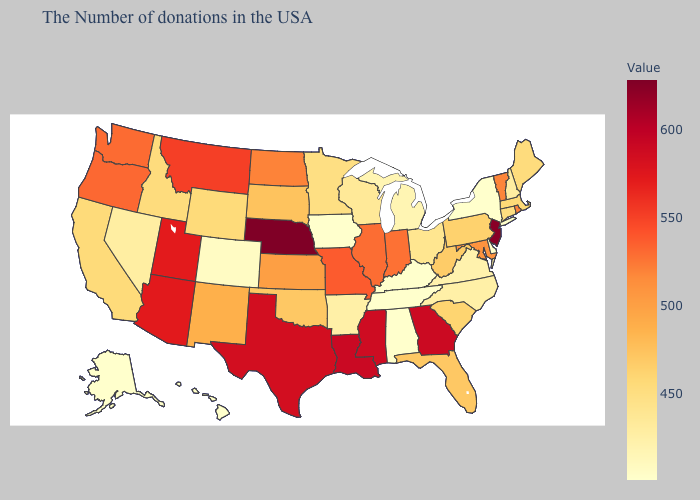Does Iowa have the lowest value in the USA?
Be succinct. Yes. Which states have the highest value in the USA?
Quick response, please. Nebraska. Which states hav the highest value in the South?
Keep it brief. Louisiana. Among the states that border Missouri , does Kentucky have the lowest value?
Keep it brief. Yes. Does the map have missing data?
Concise answer only. No. Does Delaware have the lowest value in the USA?
Keep it brief. Yes. Does Nebraska have a higher value than California?
Write a very short answer. Yes. 